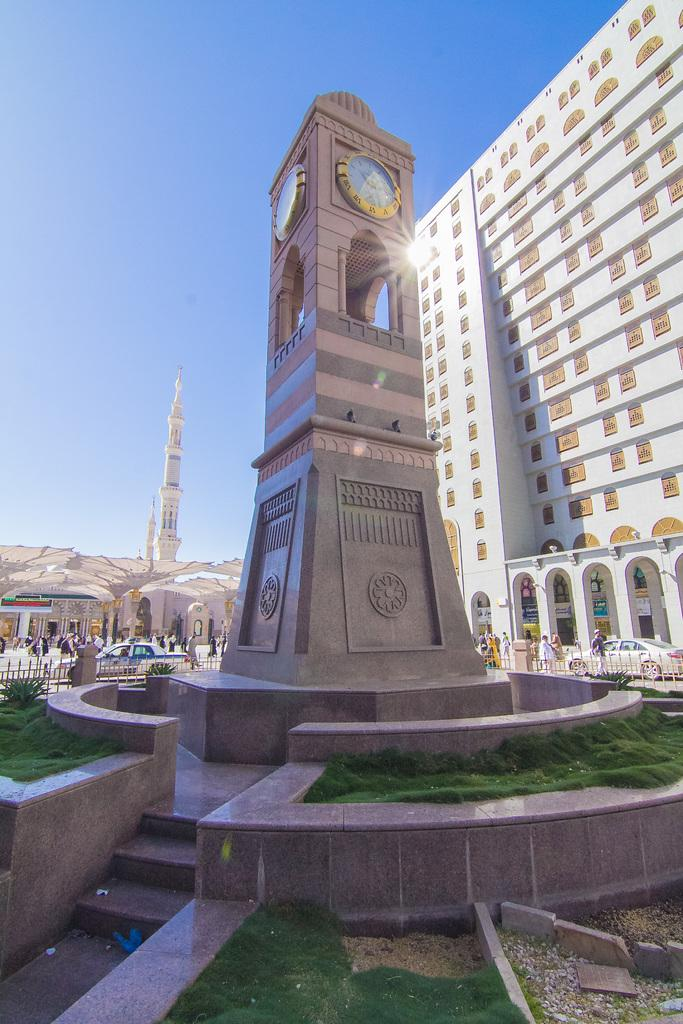What is the main subject in the middle of the image? There is a structure with a clock in the middle of the image. What can be seen on the right side of the image? There is a very big building on the right side of the image. What type of garden is located behind the clock structure in the image? There is no garden present in the image; it only features a structure with a clock and a very big building. 